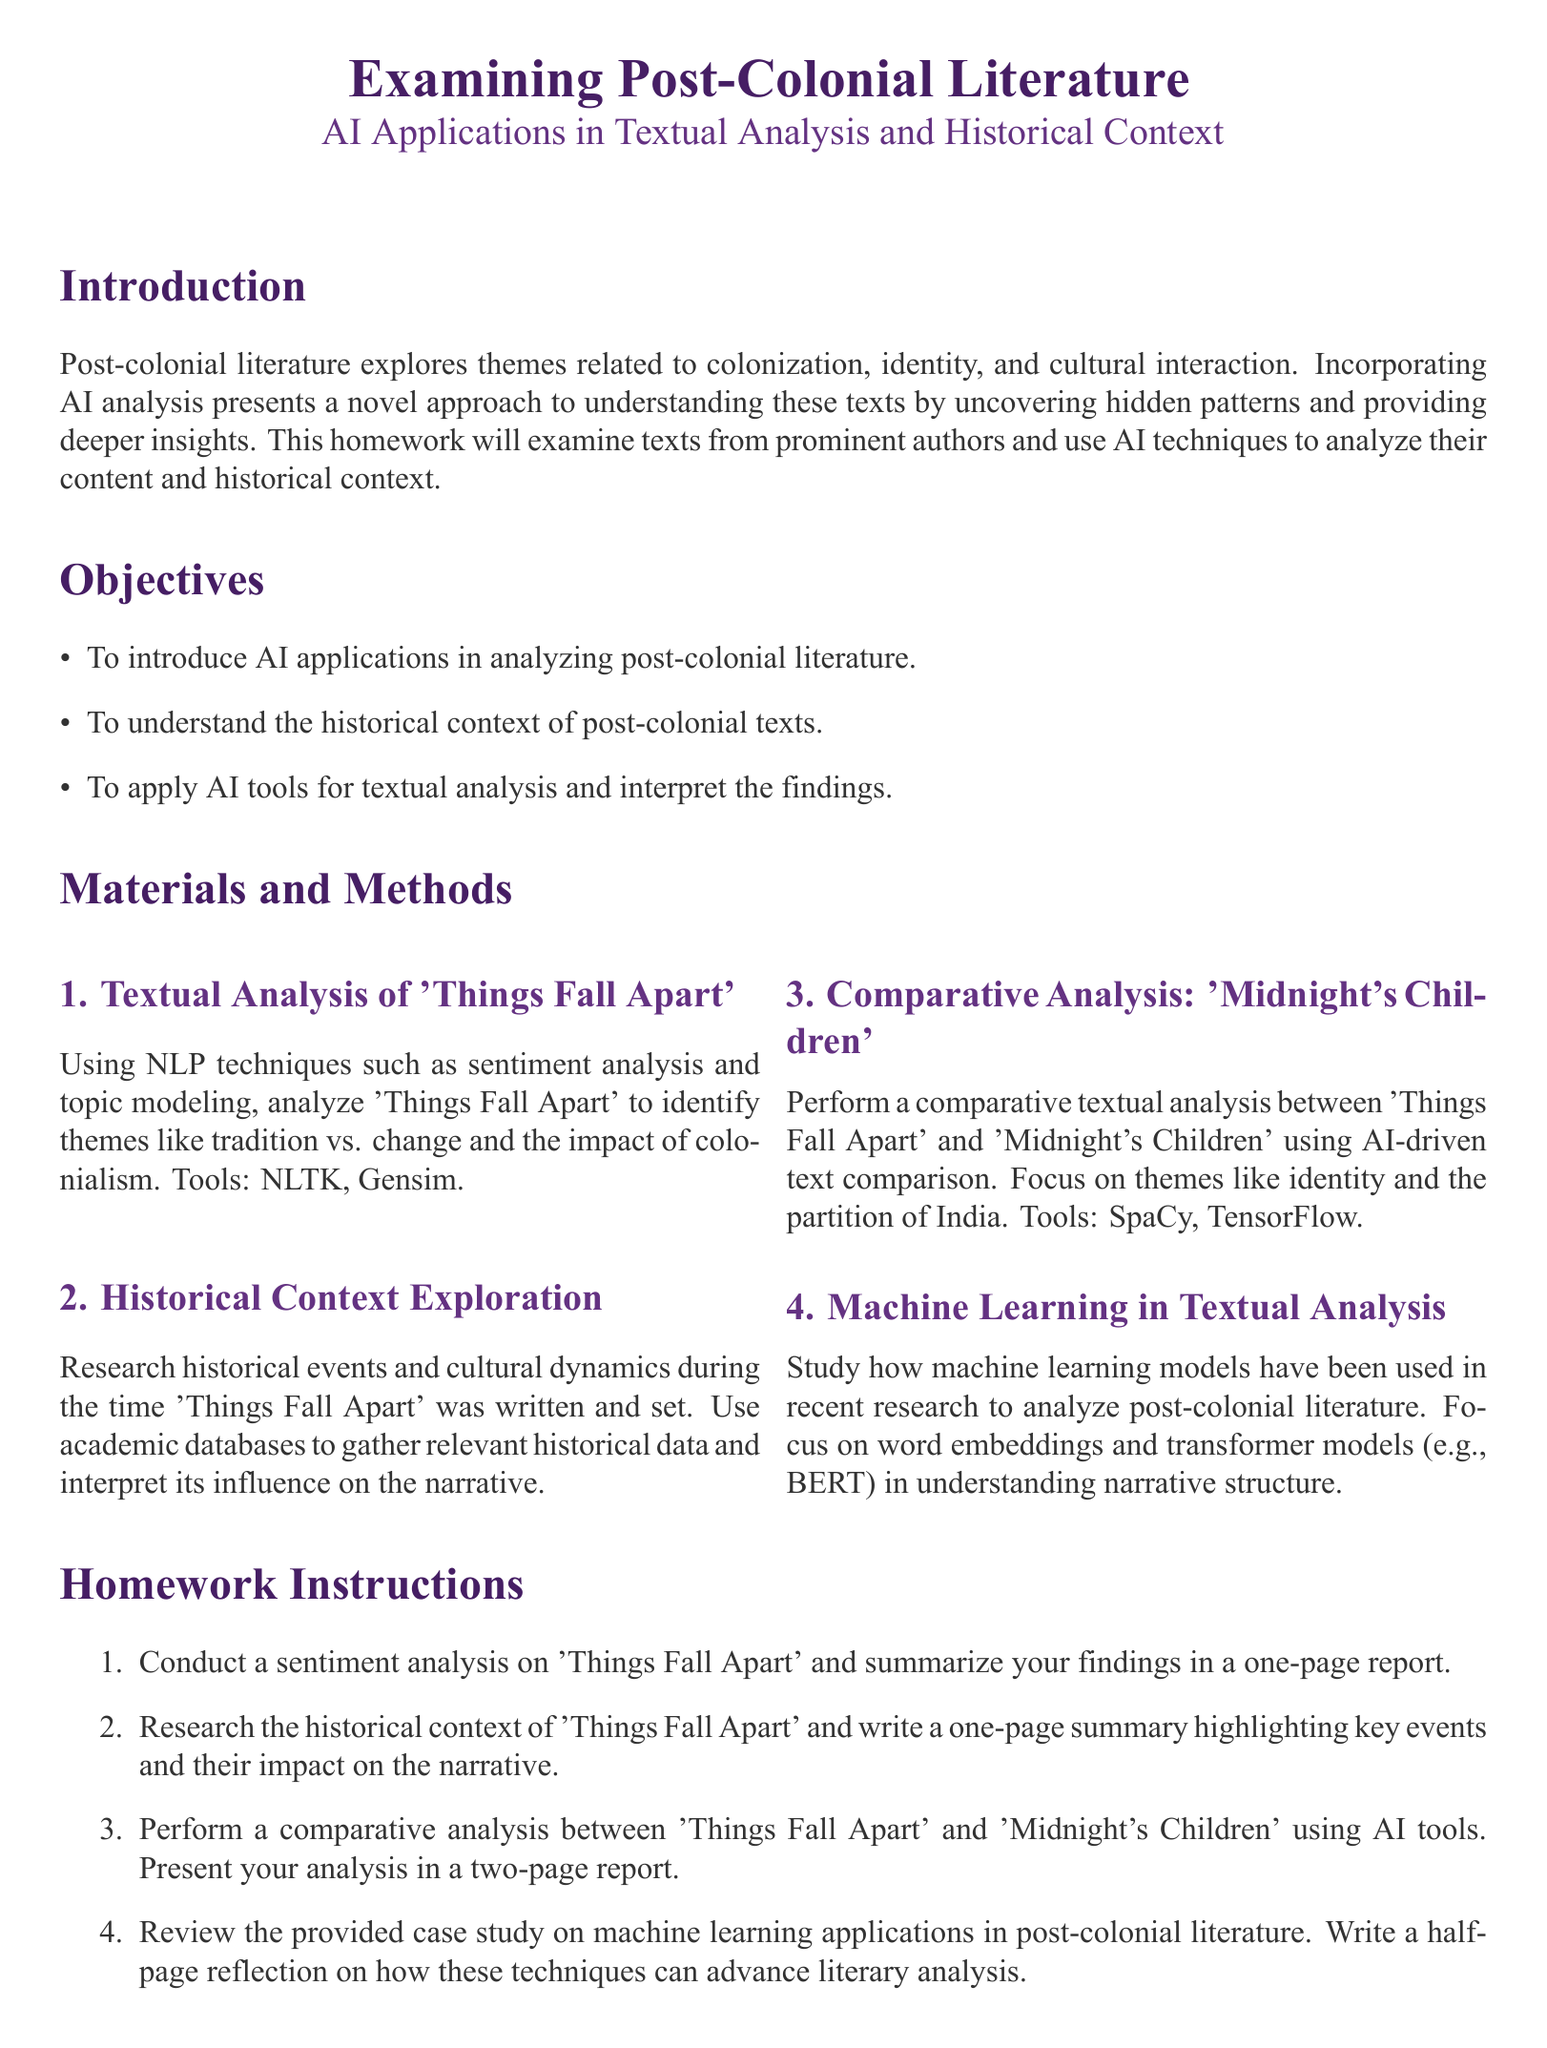what is the title of the homework? The title of the homework is prominently displayed at the top of the document.
Answer: Examining Post-Colonial Literature who is the author of 'Things Fall Apart'? The document lists the author of 'Things Fall Apart' in the references section.
Answer: Chinua Achebe which AI tool is suggested for conducting sentiment analysis? The specific AI tool for sentiment analysis is mentioned in the textual analysis section.
Answer: NLTK how many pages should the comparative analysis report be? The homework instructions specify the length of the comparative analysis report.
Answer: two-page what is one of the themes to analyze in 'Things Fall Apart'? The themes to analyze are listed in the textual analysis section.
Answer: tradition vs. change what year was 'Midnight's Children' published? The publication year of 'Midnight's Children' is noted in the references section.
Answer: 1981 what is the total number of sections in this homework document? The sections are clearly numbered and labeled in the document.
Answer: four what is the required length of the reflection on machine learning applications? The homework instructions specify the length of the reflection.
Answer: half-page 